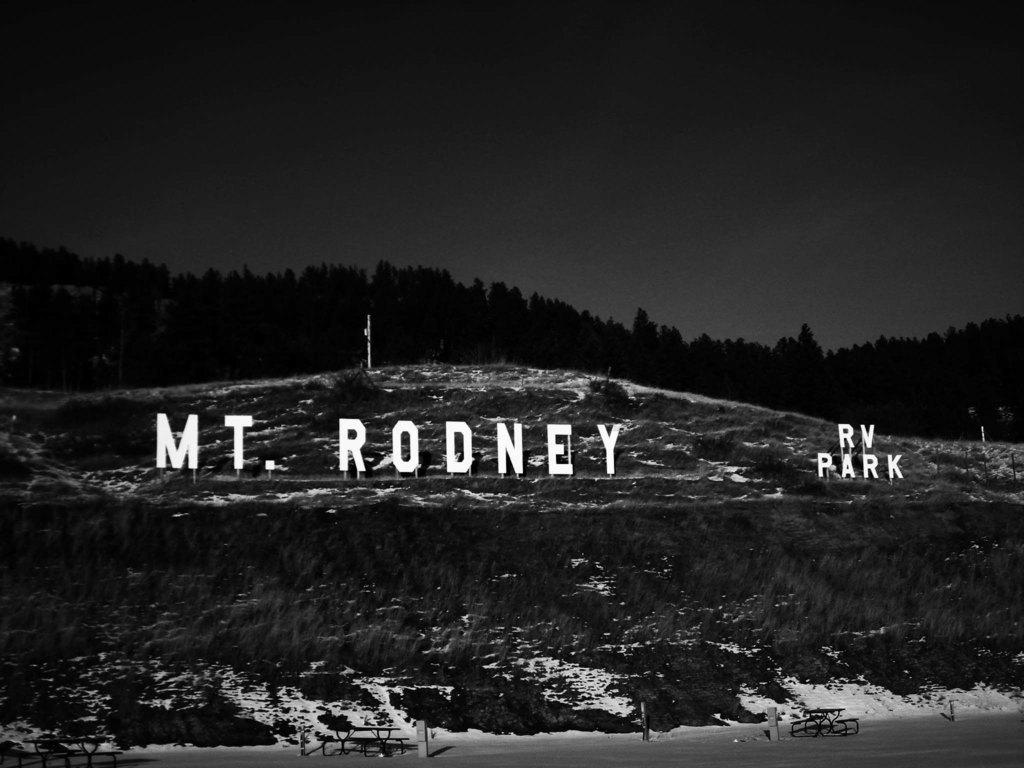Provide a one-sentence caption for the provided image. A sign that reads "MT. RODNEY RV PARK" is standing on a hillside. 